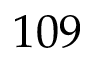<formula> <loc_0><loc_0><loc_500><loc_500>1 0 9</formula> 